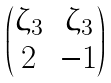<formula> <loc_0><loc_0><loc_500><loc_500>\begin{pmatrix} \zeta _ { 3 } & \zeta _ { 3 } \\ 2 & - 1 \end{pmatrix}</formula> 